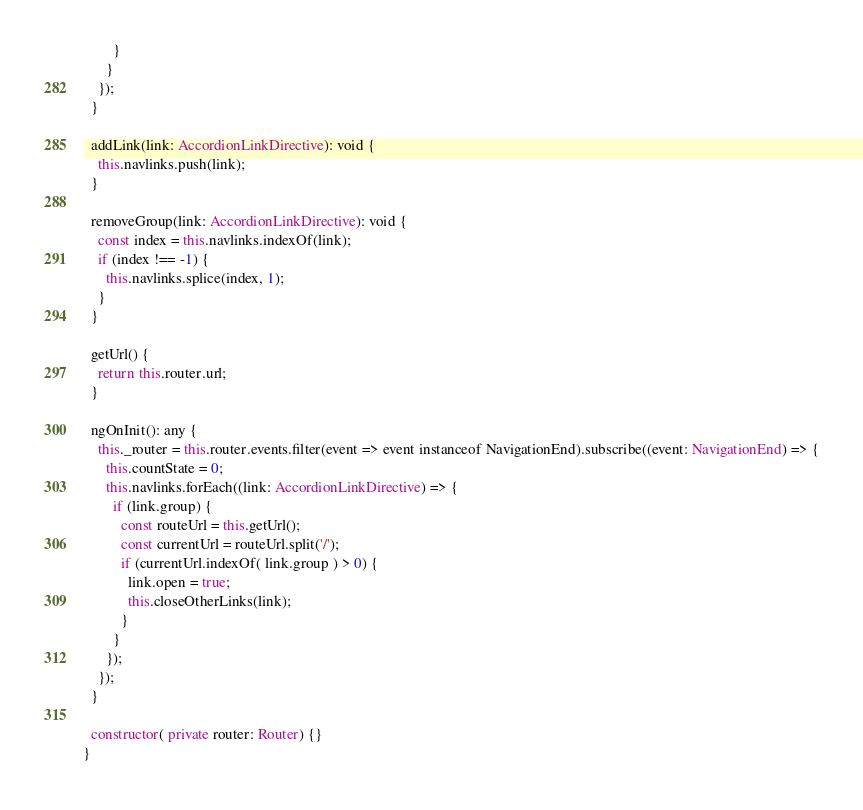Convert code to text. <code><loc_0><loc_0><loc_500><loc_500><_TypeScript_>        }
      }
    });
  }

  addLink(link: AccordionLinkDirective): void {
    this.navlinks.push(link);
  }

  removeGroup(link: AccordionLinkDirective): void {
    const index = this.navlinks.indexOf(link);
    if (index !== -1) {
      this.navlinks.splice(index, 1);
    }
  }

  getUrl() {
    return this.router.url;
  }

  ngOnInit(): any {
    this._router = this.router.events.filter(event => event instanceof NavigationEnd).subscribe((event: NavigationEnd) => {
      this.countState = 0;
      this.navlinks.forEach((link: AccordionLinkDirective) => {
        if (link.group) {
          const routeUrl = this.getUrl();
          const currentUrl = routeUrl.split('/');
          if (currentUrl.indexOf( link.group ) > 0) {
            link.open = true;
            this.closeOtherLinks(link);
          }
        }
      });
    });
  }

  constructor( private router: Router) {}
}
</code> 